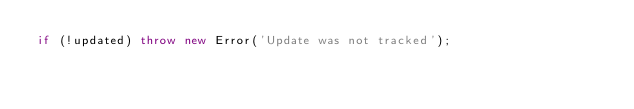<code> <loc_0><loc_0><loc_500><loc_500><_JavaScript_>if (!updated) throw new Error('Update was not tracked');
</code> 